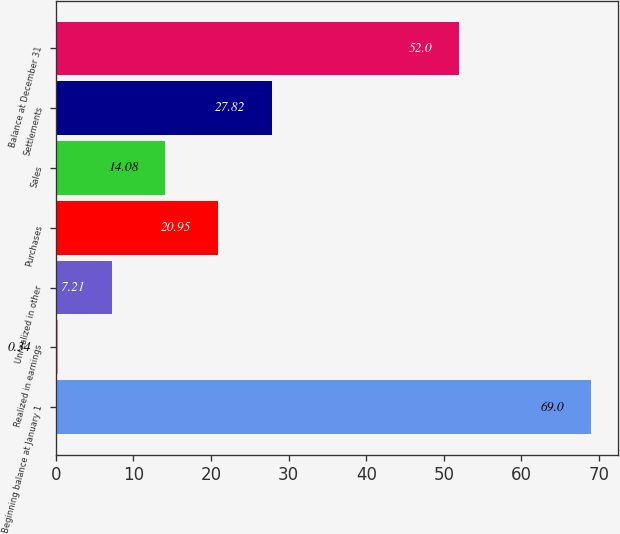Convert chart. <chart><loc_0><loc_0><loc_500><loc_500><bar_chart><fcel>Beginning balance at January 1<fcel>Realized in earnings<fcel>Unrealized in other<fcel>Purchases<fcel>Sales<fcel>Settlements<fcel>Balance at December 31<nl><fcel>69<fcel>0.34<fcel>7.21<fcel>20.95<fcel>14.08<fcel>27.82<fcel>52<nl></chart> 